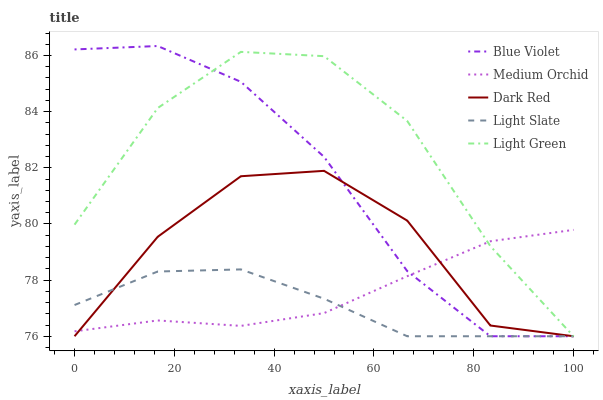Does Light Slate have the minimum area under the curve?
Answer yes or no. Yes. Does Light Green have the maximum area under the curve?
Answer yes or no. Yes. Does Dark Red have the minimum area under the curve?
Answer yes or no. No. Does Dark Red have the maximum area under the curve?
Answer yes or no. No. Is Medium Orchid the smoothest?
Answer yes or no. Yes. Is Dark Red the roughest?
Answer yes or no. Yes. Is Dark Red the smoothest?
Answer yes or no. No. Is Medium Orchid the roughest?
Answer yes or no. No. Does Medium Orchid have the lowest value?
Answer yes or no. No. Does Blue Violet have the highest value?
Answer yes or no. Yes. Does Dark Red have the highest value?
Answer yes or no. No. 